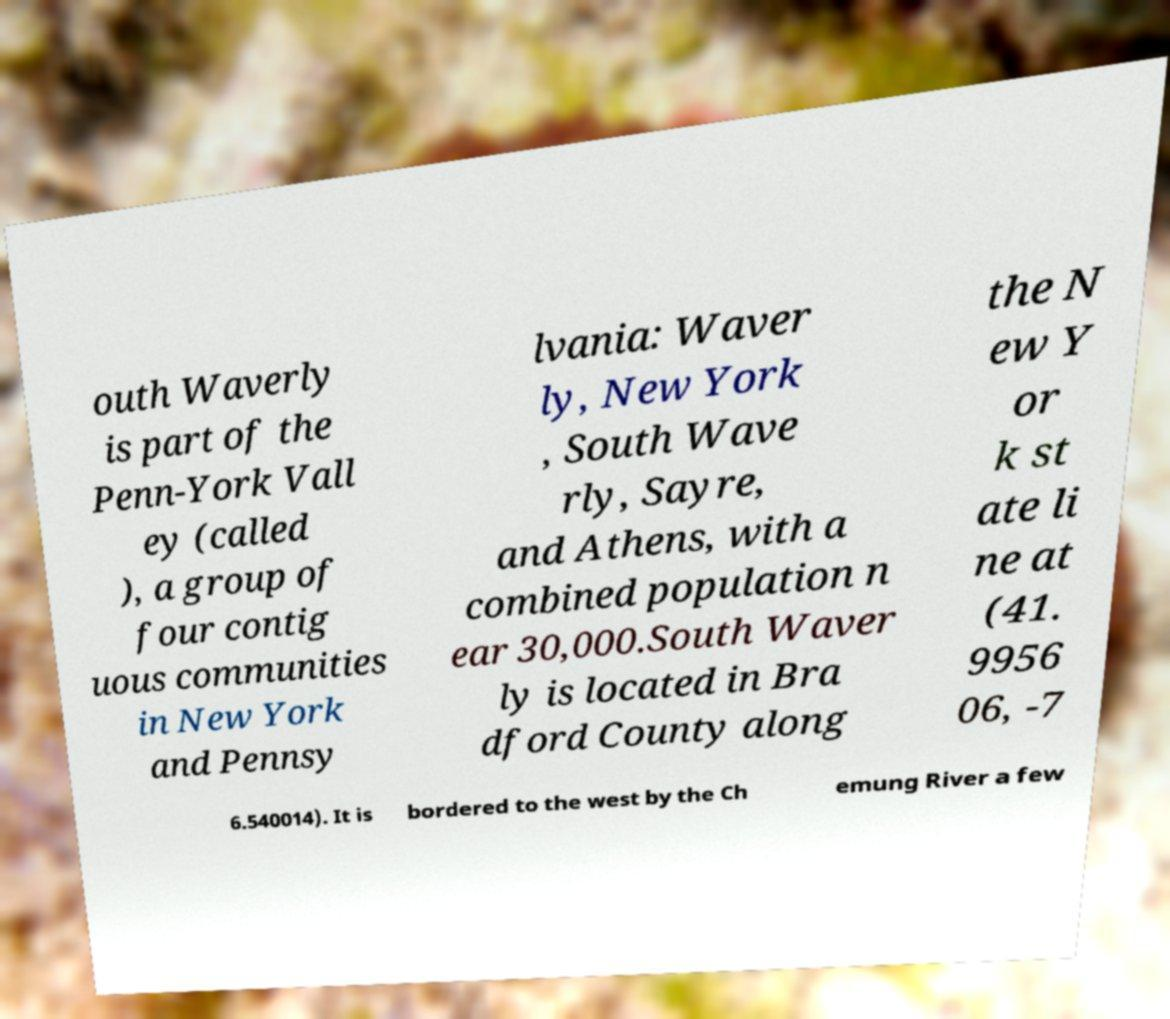Could you extract and type out the text from this image? outh Waverly is part of the Penn-York Vall ey (called ), a group of four contig uous communities in New York and Pennsy lvania: Waver ly, New York , South Wave rly, Sayre, and Athens, with a combined population n ear 30,000.South Waver ly is located in Bra dford County along the N ew Y or k st ate li ne at (41. 9956 06, -7 6.540014). It is bordered to the west by the Ch emung River a few 